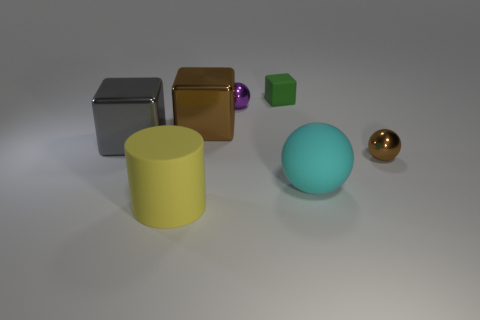Add 1 small cyan objects. How many objects exist? 8 Subtract all tiny metal balls. How many balls are left? 1 Subtract all blocks. How many objects are left? 4 Subtract all red metal blocks. Subtract all large yellow cylinders. How many objects are left? 6 Add 7 big shiny blocks. How many big shiny blocks are left? 9 Add 6 small red metal objects. How many small red metal objects exist? 6 Subtract 0 red spheres. How many objects are left? 7 Subtract 2 spheres. How many spheres are left? 1 Subtract all cyan cylinders. Subtract all red cubes. How many cylinders are left? 1 Subtract all cyan balls. How many gray blocks are left? 1 